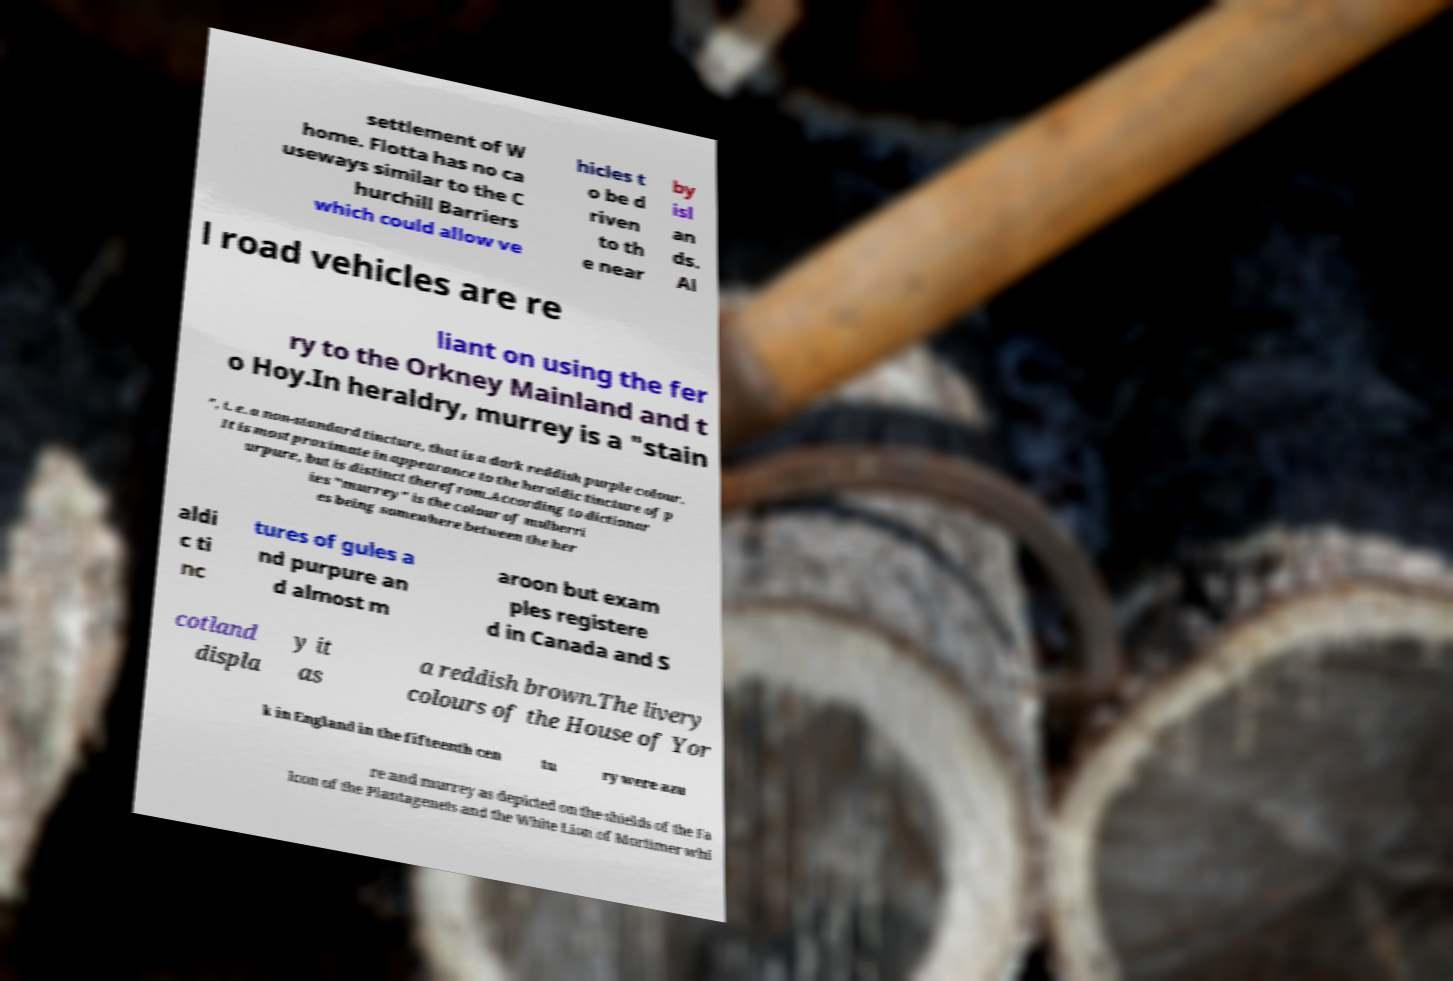Please identify and transcribe the text found in this image. settlement of W home. Flotta has no ca useways similar to the C hurchill Barriers which could allow ve hicles t o be d riven to th e near by isl an ds. Al l road vehicles are re liant on using the fer ry to the Orkney Mainland and t o Hoy.In heraldry, murrey is a "stain ", i. e. a non-standard tincture, that is a dark reddish purple colour. It is most proximate in appearance to the heraldic tincture of p urpure, but is distinct therefrom.According to dictionar ies "murrey" is the colour of mulberri es being somewhere between the her aldi c ti nc tures of gules a nd purpure an d almost m aroon but exam ples registere d in Canada and S cotland displa y it as a reddish brown.The livery colours of the House of Yor k in England in the fifteenth cen tu ry were azu re and murrey as depicted on the shields of the Fa lcon of the Plantagenets and the White Lion of Mortimer whi 